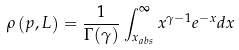Convert formula to latex. <formula><loc_0><loc_0><loc_500><loc_500>\rho \left ( p , L \right ) = \frac { 1 } { \Gamma ( \gamma ) } \int _ { x _ { a b s } } ^ { \infty } x ^ { \gamma - 1 } e ^ { - x } d x</formula> 